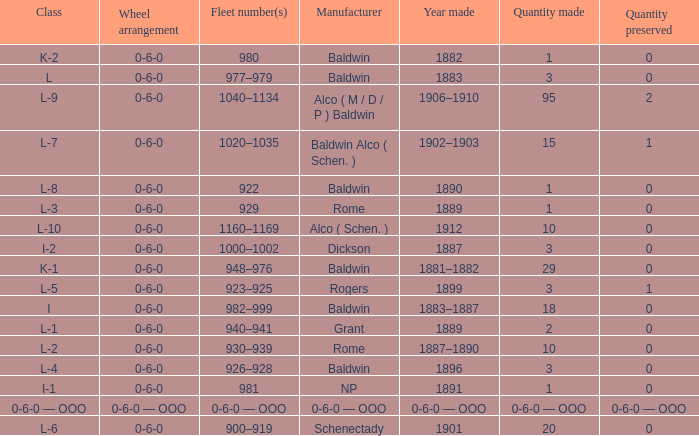Which Class has a Quantity made of 29? K-1. Parse the full table. {'header': ['Class', 'Wheel arrangement', 'Fleet number(s)', 'Manufacturer', 'Year made', 'Quantity made', 'Quantity preserved'], 'rows': [['K-2', '0-6-0', '980', 'Baldwin', '1882', '1', '0'], ['L', '0-6-0', '977–979', 'Baldwin', '1883', '3', '0'], ['L-9', '0-6-0', '1040–1134', 'Alco ( M / D / P ) Baldwin', '1906–1910', '95', '2'], ['L-7', '0-6-0', '1020–1035', 'Baldwin Alco ( Schen. )', '1902–1903', '15', '1'], ['L-8', '0-6-0', '922', 'Baldwin', '1890', '1', '0'], ['L-3', '0-6-0', '929', 'Rome', '1889', '1', '0'], ['L-10', '0-6-0', '1160–1169', 'Alco ( Schen. )', '1912', '10', '0'], ['I-2', '0-6-0', '1000–1002', 'Dickson', '1887', '3', '0'], ['K-1', '0-6-0', '948–976', 'Baldwin', '1881–1882', '29', '0'], ['L-5', '0-6-0', '923–925', 'Rogers', '1899', '3', '1'], ['I', '0-6-0', '982–999', 'Baldwin', '1883–1887', '18', '0'], ['L-1', '0-6-0', '940–941', 'Grant', '1889', '2', '0'], ['L-2', '0-6-0', '930–939', 'Rome', '1887–1890', '10', '0'], ['L-4', '0-6-0', '926–928', 'Baldwin', '1896', '3', '0'], ['I-1', '0-6-0', '981', 'NP', '1891', '1', '0'], ['0-6-0 — OOO', '0-6-0 — OOO', '0-6-0 — OOO', '0-6-0 — OOO', '0-6-0 — OOO', '0-6-0 — OOO', '0-6-0 — OOO'], ['L-6', '0-6-0', '900–919', 'Schenectady', '1901', '20', '0']]} 